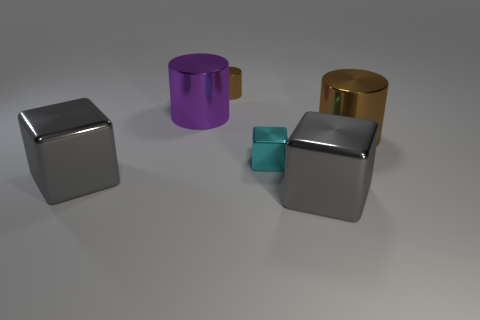Subtract all red cubes. Subtract all green spheres. How many cubes are left? 3 Add 1 red cylinders. How many objects exist? 7 Add 4 large brown things. How many large brown things exist? 5 Subtract 0 purple blocks. How many objects are left? 6 Subtract all metallic cylinders. Subtract all large purple things. How many objects are left? 2 Add 4 gray blocks. How many gray blocks are left? 6 